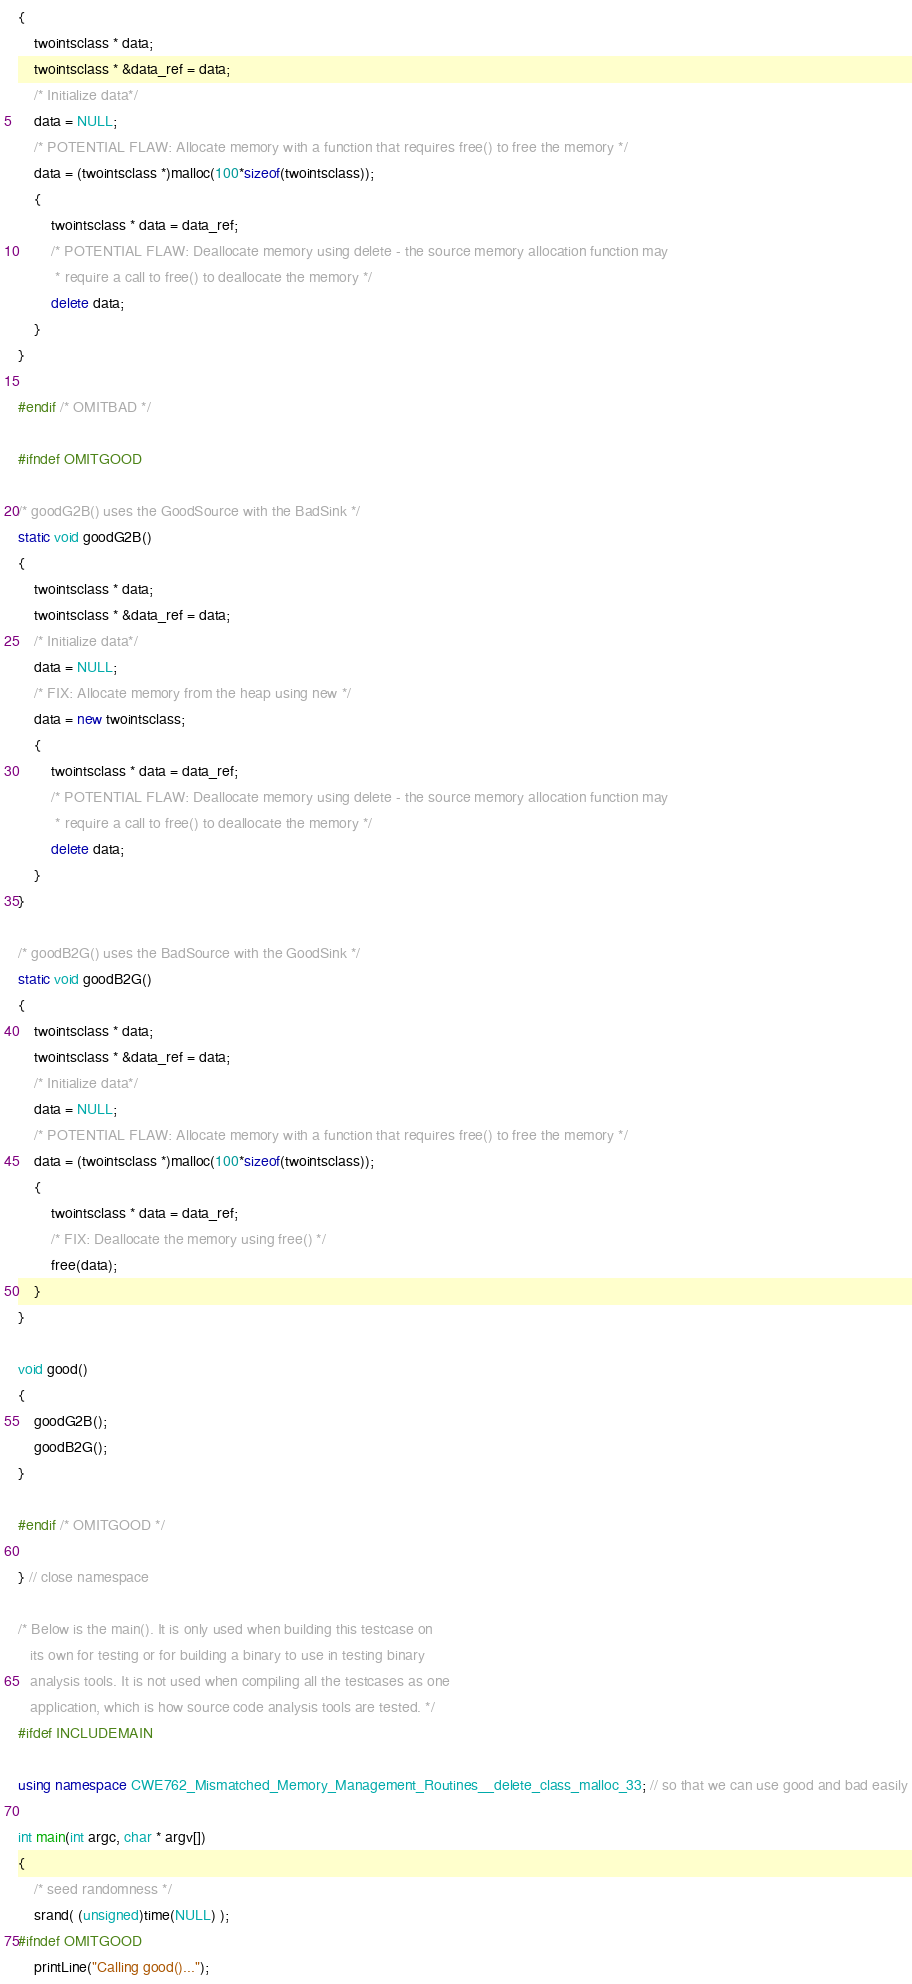<code> <loc_0><loc_0><loc_500><loc_500><_C++_>{
    twointsclass * data;
    twointsclass * &data_ref = data;
    /* Initialize data*/
    data = NULL;
    /* POTENTIAL FLAW: Allocate memory with a function that requires free() to free the memory */
    data = (twointsclass *)malloc(100*sizeof(twointsclass));
    {
        twointsclass * data = data_ref;
        /* POTENTIAL FLAW: Deallocate memory using delete - the source memory allocation function may
         * require a call to free() to deallocate the memory */
        delete data;
    }
}

#endif /* OMITBAD */

#ifndef OMITGOOD

/* goodG2B() uses the GoodSource with the BadSink */
static void goodG2B()
{
    twointsclass * data;
    twointsclass * &data_ref = data;
    /* Initialize data*/
    data = NULL;
    /* FIX: Allocate memory from the heap using new */
    data = new twointsclass;
    {
        twointsclass * data = data_ref;
        /* POTENTIAL FLAW: Deallocate memory using delete - the source memory allocation function may
         * require a call to free() to deallocate the memory */
        delete data;
    }
}

/* goodB2G() uses the BadSource with the GoodSink */
static void goodB2G()
{
    twointsclass * data;
    twointsclass * &data_ref = data;
    /* Initialize data*/
    data = NULL;
    /* POTENTIAL FLAW: Allocate memory with a function that requires free() to free the memory */
    data = (twointsclass *)malloc(100*sizeof(twointsclass));
    {
        twointsclass * data = data_ref;
        /* FIX: Deallocate the memory using free() */
        free(data);
    }
}

void good()
{
    goodG2B();
    goodB2G();
}

#endif /* OMITGOOD */

} // close namespace

/* Below is the main(). It is only used when building this testcase on
   its own for testing or for building a binary to use in testing binary
   analysis tools. It is not used when compiling all the testcases as one
   application, which is how source code analysis tools are tested. */
#ifdef INCLUDEMAIN

using namespace CWE762_Mismatched_Memory_Management_Routines__delete_class_malloc_33; // so that we can use good and bad easily

int main(int argc, char * argv[])
{
    /* seed randomness */
    srand( (unsigned)time(NULL) );
#ifndef OMITGOOD
    printLine("Calling good()...");</code> 